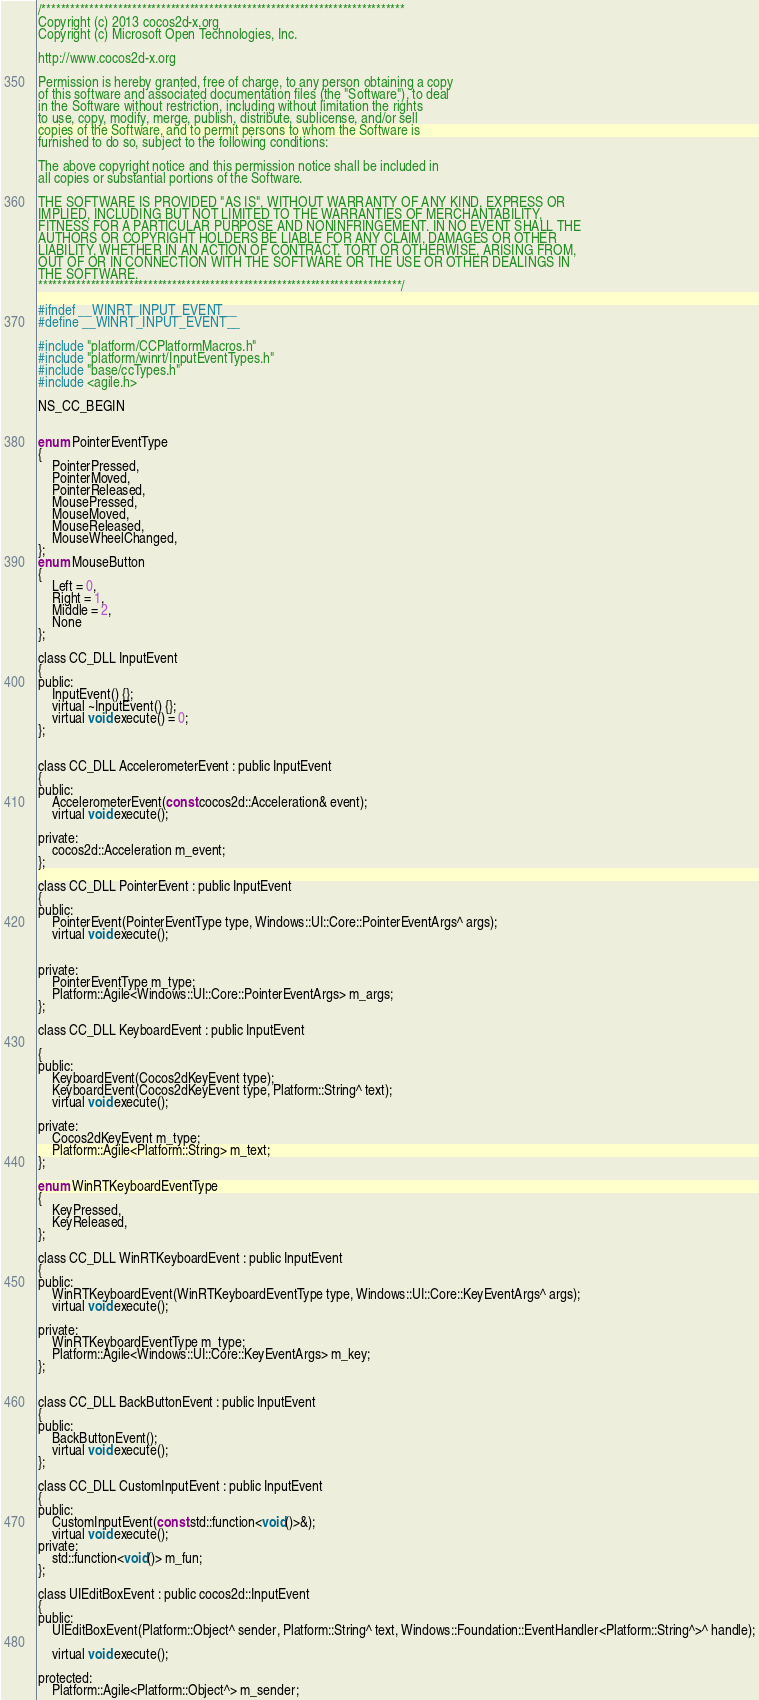<code> <loc_0><loc_0><loc_500><loc_500><_C_>/****************************************************************************
Copyright (c) 2013 cocos2d-x.org
Copyright (c) Microsoft Open Technologies, Inc.

http://www.cocos2d-x.org

Permission is hereby granted, free of charge, to any person obtaining a copy
of this software and associated documentation files (the "Software"), to deal
in the Software without restriction, including without limitation the rights
to use, copy, modify, merge, publish, distribute, sublicense, and/or sell
copies of the Software, and to permit persons to whom the Software is
furnished to do so, subject to the following conditions:

The above copyright notice and this permission notice shall be included in
all copies or substantial portions of the Software.

THE SOFTWARE IS PROVIDED "AS IS", WITHOUT WARRANTY OF ANY KIND, EXPRESS OR
IMPLIED, INCLUDING BUT NOT LIMITED TO THE WARRANTIES OF MERCHANTABILITY,
FITNESS FOR A PARTICULAR PURPOSE AND NONINFRINGEMENT. IN NO EVENT SHALL THE
AUTHORS OR COPYRIGHT HOLDERS BE LIABLE FOR ANY CLAIM, DAMAGES OR OTHER
LIABILITY, WHETHER IN AN ACTION OF CONTRACT, TORT OR OTHERWISE, ARISING FROM,
OUT OF OR IN CONNECTION WITH THE SOFTWARE OR THE USE OR OTHER DEALINGS IN
THE SOFTWARE.
****************************************************************************/

#ifndef __WINRT_INPUT_EVENT__
#define __WINRT_INPUT_EVENT__

#include "platform/CCPlatformMacros.h"
#include "platform/winrt/InputEventTypes.h"
#include "base/ccTypes.h"
#include <agile.h>

NS_CC_BEGIN


enum PointerEventType
{
    PointerPressed,
    PointerMoved,
    PointerReleased,
    MousePressed,
    MouseMoved,
    MouseReleased,
    MouseWheelChanged,
};
enum MouseButton
{
    Left = 0,
    Right = 1,
    Middle = 2,
    None
};

class CC_DLL InputEvent
{
public:
    InputEvent() {};
    virtual ~InputEvent() {};
    virtual void execute() = 0;
};


class CC_DLL AccelerometerEvent : public InputEvent
{
public:
    AccelerometerEvent(const cocos2d::Acceleration& event);
    virtual void execute();

private:
    cocos2d::Acceleration m_event;
};

class CC_DLL PointerEvent : public InputEvent
{
public:
    PointerEvent(PointerEventType type, Windows::UI::Core::PointerEventArgs^ args);
    virtual void execute();


private:
    PointerEventType m_type;
    Platform::Agile<Windows::UI::Core::PointerEventArgs> m_args;
};

class CC_DLL KeyboardEvent : public InputEvent

{
public:
    KeyboardEvent(Cocos2dKeyEvent type);
    KeyboardEvent(Cocos2dKeyEvent type, Platform::String^ text);
    virtual void execute();

private:
    Cocos2dKeyEvent m_type;
    Platform::Agile<Platform::String> m_text;
};

enum WinRTKeyboardEventType
{
	KeyPressed,
	KeyReleased,
};

class CC_DLL WinRTKeyboardEvent : public InputEvent
{
public:
	WinRTKeyboardEvent(WinRTKeyboardEventType type, Windows::UI::Core::KeyEventArgs^ args);
	virtual void execute();

private:
	WinRTKeyboardEventType m_type;
	Platform::Agile<Windows::UI::Core::KeyEventArgs> m_key;
};


class CC_DLL BackButtonEvent : public InputEvent
{
public:
    BackButtonEvent();
    virtual void execute();
};

class CC_DLL CustomInputEvent : public InputEvent
{
public:
    CustomInputEvent(const std::function<void()>&);
    virtual void execute();
private:
    std::function<void()> m_fun;
};

class UIEditBoxEvent : public cocos2d::InputEvent
{
public:
    UIEditBoxEvent(Platform::Object^ sender, Platform::String^ text, Windows::Foundation::EventHandler<Platform::String^>^ handle);

    virtual void execute();

protected:
    Platform::Agile<Platform::Object^> m_sender;</code> 